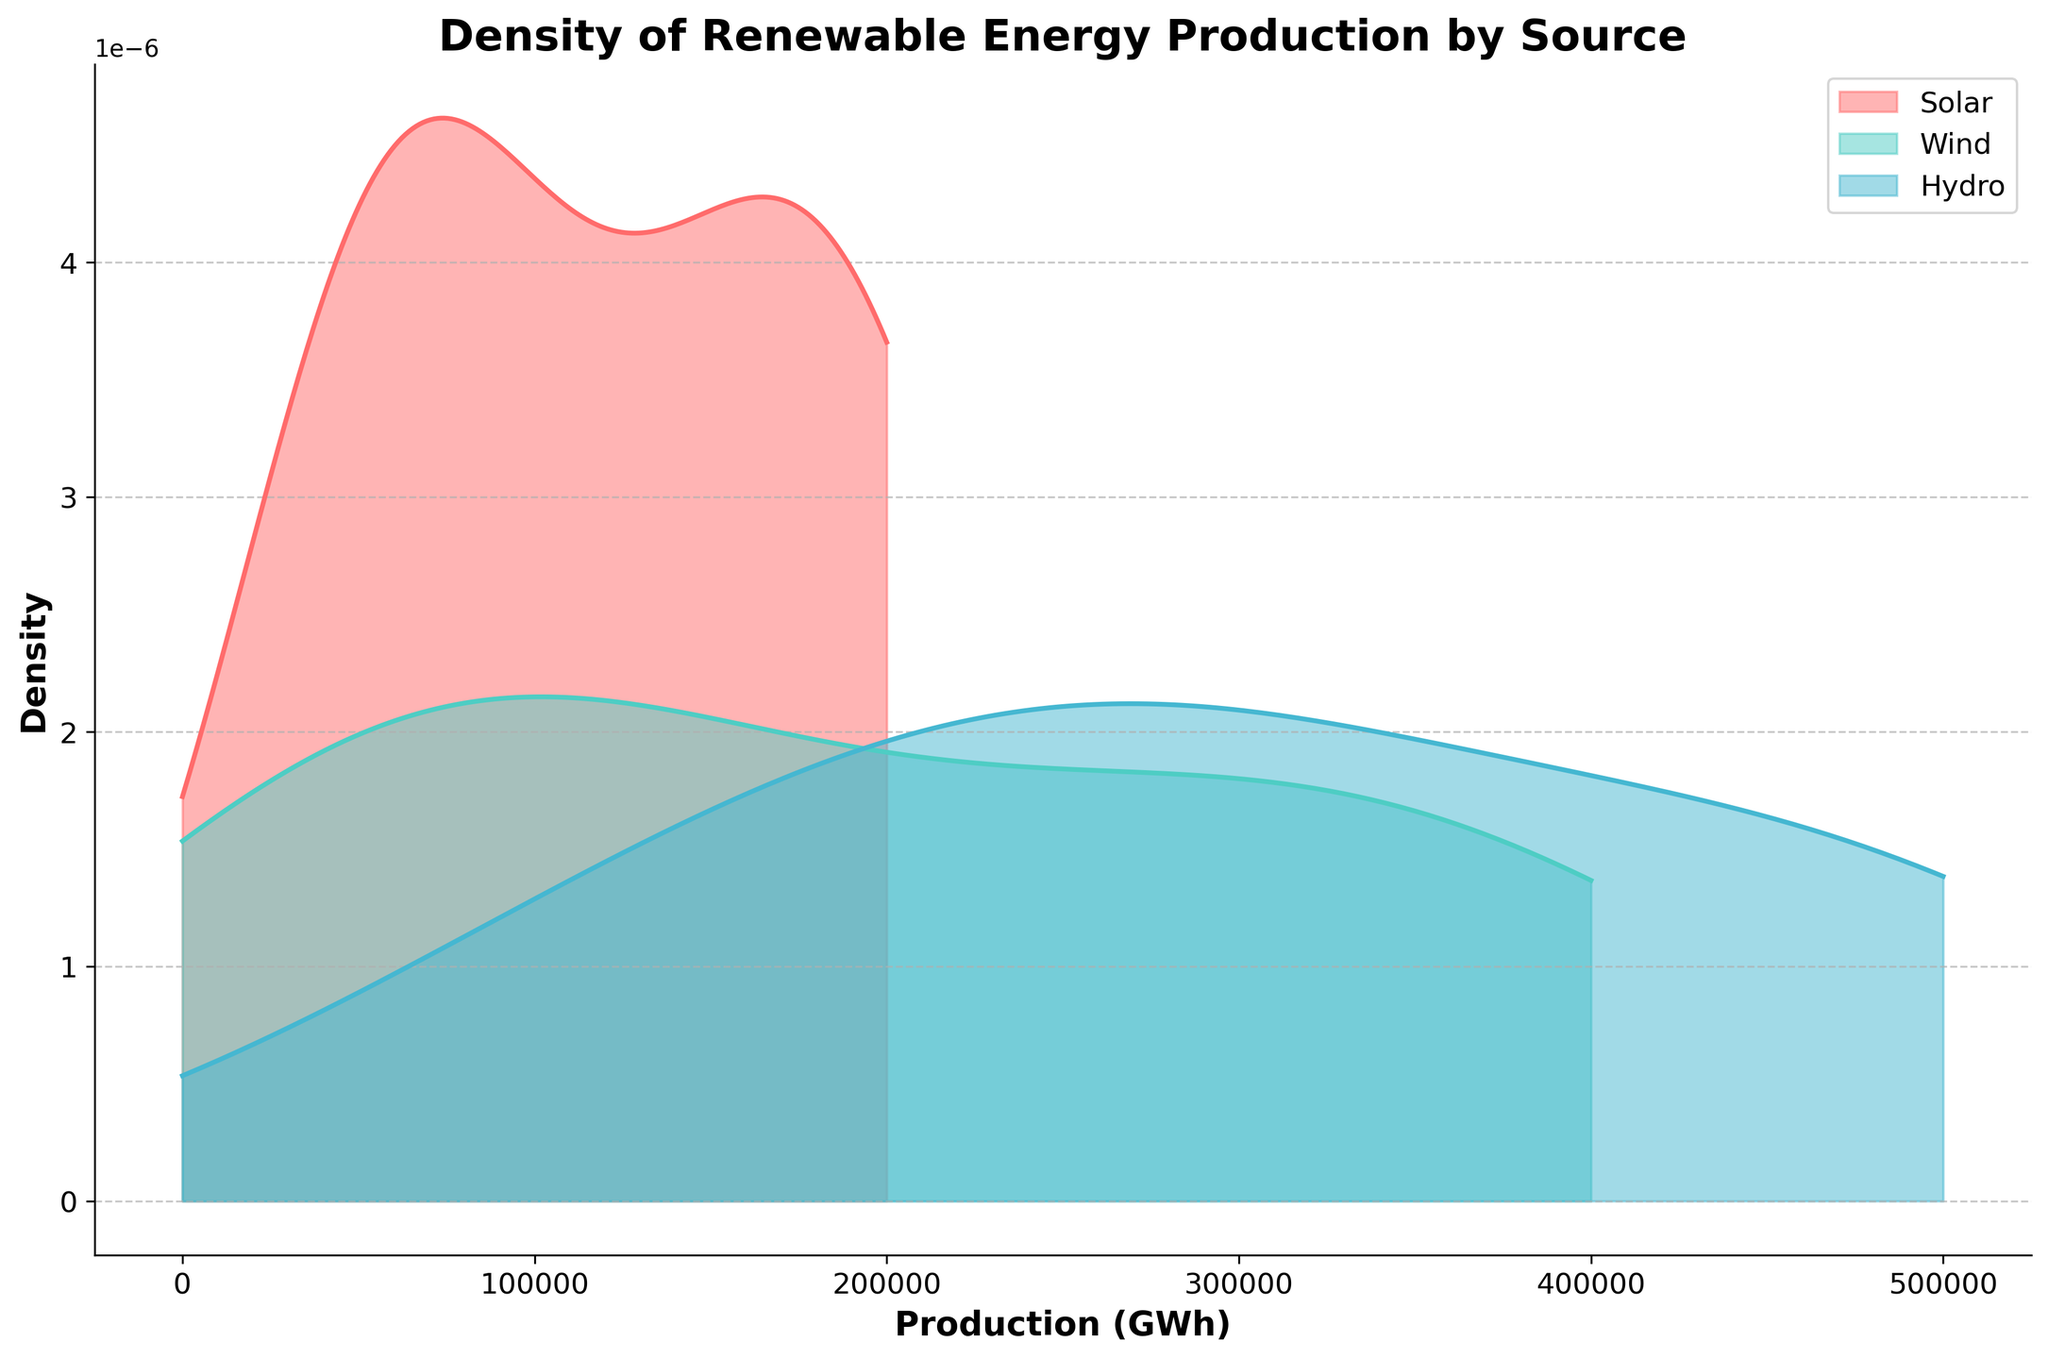What's the title of the figure? The title can be found at the top of the figure, and it is usually intended to give a summary of what the plot represents.
Answer: Density of Renewable Energy Production by Source What are the labels of the X and Y axes? The labels are usually mentioned along the axes. The X axis represents 'Production (GWh)' and the Y axis represents 'Density'.
Answer: Production (GWh), Density Which renewable energy source has the widest distribution in production GWh? To determine this, observe the range of the x-axis covered by the density curves of each renewable energy source.
Answer: Hydro Which renewable energy source has the highest peak density? The peak density can be determined by looking at the highest point of the density curves for each source.
Answer: Wind How do the density plots for Solar and Wind compare in terms of production GWh? To compare, look at the density curves of Solar and Wind sources specifically how they overlap or differ in the x-axis range. While both have peaks at different points, Wind generally shows a higher production range than Solar.
Answer: Wind has a broader and higher production range than Solar Among the different energy sources, which one shows the least variability in production GWh? Variability can be assessed by the spread of the density plot along the x-axis. The one with the narrowest spread indicates the least variability.
Answer: Solar What's the approximate range of hydro energy production? The range can be determined by looking at the spread of the hydro density plot along the x-axis. It ranges approximately from 0 to above 500,000 GWh.
Answer: 0 to above 500,000 GWh Is there any renewable energy source where the production GWh values are tightly clustered around a central value? Tight clustering around a central value would mean a narrower and higher peak density plot.
Answer: Solar What's a notable difference between the Hydro and Solar density plots? The notable difference can be seen by comparing the spread and peak densities of the two plots.
Answer: Hydro has a much wider spread, while Solar has a narrower and more centralized peak 